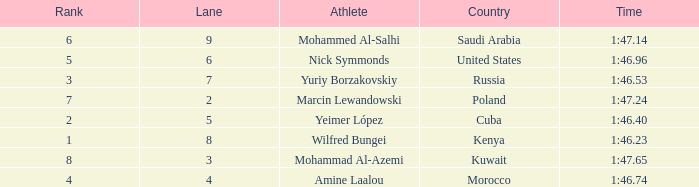What is the Rank of the Athlete with a Time of 1:47.65 and in Lane 3 or larger? None. 